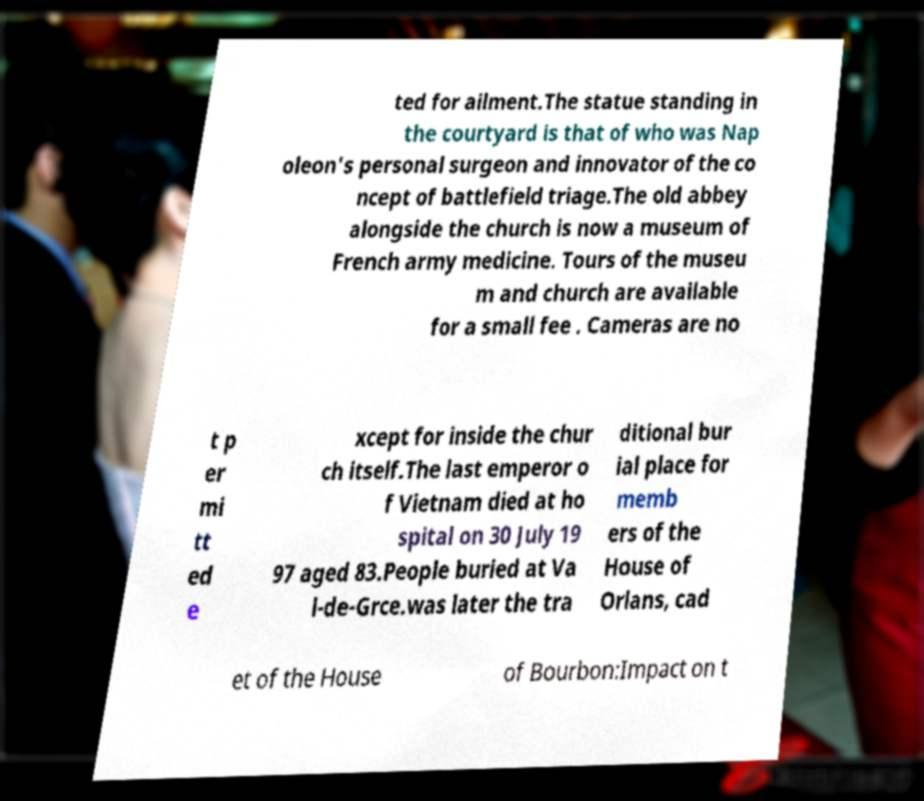Can you read and provide the text displayed in the image?This photo seems to have some interesting text. Can you extract and type it out for me? ted for ailment.The statue standing in the courtyard is that of who was Nap oleon's personal surgeon and innovator of the co ncept of battlefield triage.The old abbey alongside the church is now a museum of French army medicine. Tours of the museu m and church are available for a small fee . Cameras are no t p er mi tt ed e xcept for inside the chur ch itself.The last emperor o f Vietnam died at ho spital on 30 July 19 97 aged 83.People buried at Va l-de-Grce.was later the tra ditional bur ial place for memb ers of the House of Orlans, cad et of the House of Bourbon:Impact on t 